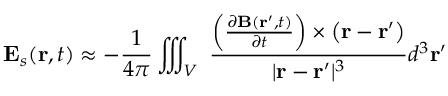<formula> <loc_0><loc_0><loc_500><loc_500>E _ { s } ( r , t ) \approx - { \frac { 1 } { 4 \pi } } \iiint _ { V } \ { \frac { \left ( { \frac { \partial B ( r ^ { \prime } , t ) } { \partial t } } \right ) \times \left ( r - r ^ { \prime } \right ) } { | r - r ^ { \prime } | ^ { 3 } } } d ^ { 3 } r ^ { \prime }</formula> 